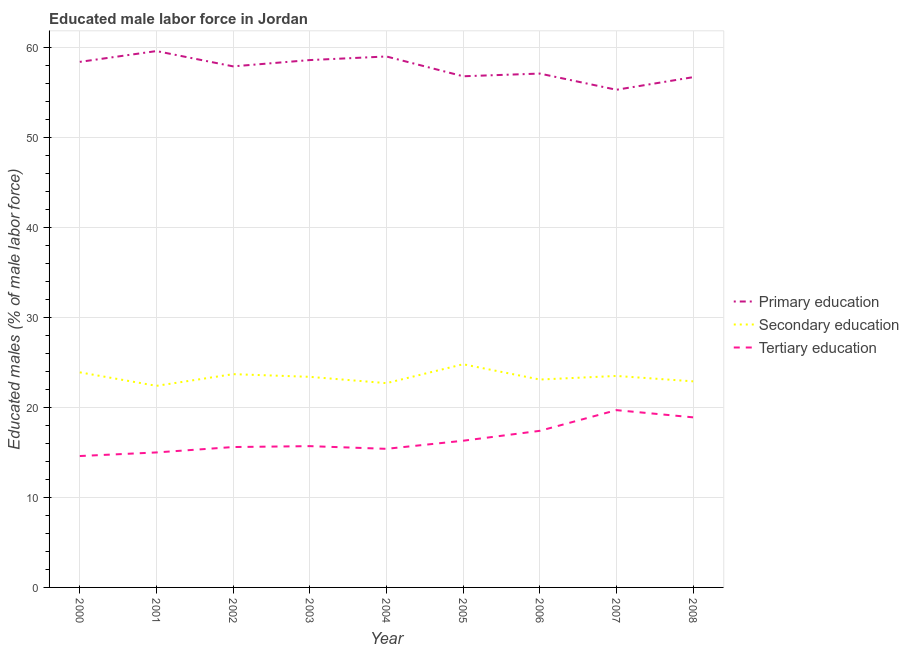What is the percentage of male labor force who received primary education in 2008?
Your answer should be very brief. 56.7. Across all years, what is the maximum percentage of male labor force who received secondary education?
Ensure brevity in your answer.  24.8. Across all years, what is the minimum percentage of male labor force who received secondary education?
Provide a succinct answer. 22.4. In which year was the percentage of male labor force who received primary education maximum?
Give a very brief answer. 2001. In which year was the percentage of male labor force who received secondary education minimum?
Your answer should be compact. 2001. What is the total percentage of male labor force who received tertiary education in the graph?
Provide a short and direct response. 148.6. What is the difference between the percentage of male labor force who received secondary education in 2000 and that in 2005?
Provide a succinct answer. -0.9. What is the difference between the percentage of male labor force who received tertiary education in 2007 and the percentage of male labor force who received primary education in 2003?
Make the answer very short. -38.9. What is the average percentage of male labor force who received tertiary education per year?
Your answer should be compact. 16.51. In the year 2005, what is the difference between the percentage of male labor force who received tertiary education and percentage of male labor force who received primary education?
Offer a terse response. -40.5. In how many years, is the percentage of male labor force who received secondary education greater than 56 %?
Your response must be concise. 0. What is the ratio of the percentage of male labor force who received secondary education in 2001 to that in 2008?
Keep it short and to the point. 0.98. Is the percentage of male labor force who received secondary education in 2000 less than that in 2001?
Give a very brief answer. No. What is the difference between the highest and the second highest percentage of male labor force who received primary education?
Ensure brevity in your answer.  0.6. What is the difference between the highest and the lowest percentage of male labor force who received secondary education?
Your answer should be very brief. 2.4. Does the percentage of male labor force who received primary education monotonically increase over the years?
Provide a succinct answer. No. Is the percentage of male labor force who received primary education strictly greater than the percentage of male labor force who received secondary education over the years?
Provide a succinct answer. Yes. Is the percentage of male labor force who received primary education strictly less than the percentage of male labor force who received secondary education over the years?
Your answer should be very brief. No. How many lines are there?
Provide a succinct answer. 3. How many years are there in the graph?
Your answer should be compact. 9. What is the difference between two consecutive major ticks on the Y-axis?
Your answer should be compact. 10. Does the graph contain any zero values?
Your answer should be very brief. No. Where does the legend appear in the graph?
Your response must be concise. Center right. How are the legend labels stacked?
Keep it short and to the point. Vertical. What is the title of the graph?
Offer a terse response. Educated male labor force in Jordan. Does "Social Protection" appear as one of the legend labels in the graph?
Offer a terse response. No. What is the label or title of the X-axis?
Give a very brief answer. Year. What is the label or title of the Y-axis?
Make the answer very short. Educated males (% of male labor force). What is the Educated males (% of male labor force) of Primary education in 2000?
Provide a short and direct response. 58.4. What is the Educated males (% of male labor force) in Secondary education in 2000?
Your answer should be very brief. 23.9. What is the Educated males (% of male labor force) of Tertiary education in 2000?
Your answer should be very brief. 14.6. What is the Educated males (% of male labor force) of Primary education in 2001?
Keep it short and to the point. 59.6. What is the Educated males (% of male labor force) of Secondary education in 2001?
Offer a very short reply. 22.4. What is the Educated males (% of male labor force) in Primary education in 2002?
Provide a short and direct response. 57.9. What is the Educated males (% of male labor force) of Secondary education in 2002?
Your response must be concise. 23.7. What is the Educated males (% of male labor force) of Tertiary education in 2002?
Offer a very short reply. 15.6. What is the Educated males (% of male labor force) of Primary education in 2003?
Your answer should be very brief. 58.6. What is the Educated males (% of male labor force) of Secondary education in 2003?
Make the answer very short. 23.4. What is the Educated males (% of male labor force) of Tertiary education in 2003?
Offer a very short reply. 15.7. What is the Educated males (% of male labor force) in Secondary education in 2004?
Keep it short and to the point. 22.7. What is the Educated males (% of male labor force) in Tertiary education in 2004?
Your answer should be compact. 15.4. What is the Educated males (% of male labor force) in Primary education in 2005?
Your answer should be very brief. 56.8. What is the Educated males (% of male labor force) in Secondary education in 2005?
Your answer should be compact. 24.8. What is the Educated males (% of male labor force) of Tertiary education in 2005?
Give a very brief answer. 16.3. What is the Educated males (% of male labor force) in Primary education in 2006?
Offer a very short reply. 57.1. What is the Educated males (% of male labor force) of Secondary education in 2006?
Provide a short and direct response. 23.1. What is the Educated males (% of male labor force) in Tertiary education in 2006?
Your answer should be very brief. 17.4. What is the Educated males (% of male labor force) in Primary education in 2007?
Give a very brief answer. 55.3. What is the Educated males (% of male labor force) in Secondary education in 2007?
Offer a very short reply. 23.5. What is the Educated males (% of male labor force) in Tertiary education in 2007?
Your answer should be very brief. 19.7. What is the Educated males (% of male labor force) in Primary education in 2008?
Your response must be concise. 56.7. What is the Educated males (% of male labor force) of Secondary education in 2008?
Your response must be concise. 22.9. What is the Educated males (% of male labor force) in Tertiary education in 2008?
Your response must be concise. 18.9. Across all years, what is the maximum Educated males (% of male labor force) of Primary education?
Provide a short and direct response. 59.6. Across all years, what is the maximum Educated males (% of male labor force) of Secondary education?
Ensure brevity in your answer.  24.8. Across all years, what is the maximum Educated males (% of male labor force) of Tertiary education?
Ensure brevity in your answer.  19.7. Across all years, what is the minimum Educated males (% of male labor force) of Primary education?
Give a very brief answer. 55.3. Across all years, what is the minimum Educated males (% of male labor force) of Secondary education?
Your response must be concise. 22.4. Across all years, what is the minimum Educated males (% of male labor force) of Tertiary education?
Keep it short and to the point. 14.6. What is the total Educated males (% of male labor force) in Primary education in the graph?
Offer a terse response. 519.4. What is the total Educated males (% of male labor force) of Secondary education in the graph?
Offer a terse response. 210.4. What is the total Educated males (% of male labor force) in Tertiary education in the graph?
Your response must be concise. 148.6. What is the difference between the Educated males (% of male labor force) of Primary education in 2000 and that in 2001?
Offer a terse response. -1.2. What is the difference between the Educated males (% of male labor force) in Tertiary education in 2000 and that in 2001?
Provide a short and direct response. -0.4. What is the difference between the Educated males (% of male labor force) in Primary education in 2000 and that in 2002?
Your answer should be compact. 0.5. What is the difference between the Educated males (% of male labor force) of Secondary education in 2000 and that in 2002?
Keep it short and to the point. 0.2. What is the difference between the Educated males (% of male labor force) of Secondary education in 2000 and that in 2003?
Offer a terse response. 0.5. What is the difference between the Educated males (% of male labor force) of Secondary education in 2000 and that in 2004?
Ensure brevity in your answer.  1.2. What is the difference between the Educated males (% of male labor force) of Tertiary education in 2000 and that in 2004?
Offer a terse response. -0.8. What is the difference between the Educated males (% of male labor force) in Primary education in 2000 and that in 2005?
Make the answer very short. 1.6. What is the difference between the Educated males (% of male labor force) in Secondary education in 2000 and that in 2005?
Your response must be concise. -0.9. What is the difference between the Educated males (% of male labor force) of Tertiary education in 2000 and that in 2005?
Keep it short and to the point. -1.7. What is the difference between the Educated males (% of male labor force) of Primary education in 2000 and that in 2006?
Offer a terse response. 1.3. What is the difference between the Educated males (% of male labor force) in Secondary education in 2000 and that in 2006?
Your answer should be compact. 0.8. What is the difference between the Educated males (% of male labor force) in Secondary education in 2000 and that in 2007?
Offer a terse response. 0.4. What is the difference between the Educated males (% of male labor force) of Secondary education in 2000 and that in 2008?
Make the answer very short. 1. What is the difference between the Educated males (% of male labor force) in Tertiary education in 2000 and that in 2008?
Your answer should be very brief. -4.3. What is the difference between the Educated males (% of male labor force) in Secondary education in 2001 and that in 2002?
Your response must be concise. -1.3. What is the difference between the Educated males (% of male labor force) of Tertiary education in 2001 and that in 2002?
Your answer should be compact. -0.6. What is the difference between the Educated males (% of male labor force) in Primary education in 2001 and that in 2003?
Give a very brief answer. 1. What is the difference between the Educated males (% of male labor force) in Tertiary education in 2001 and that in 2003?
Offer a terse response. -0.7. What is the difference between the Educated males (% of male labor force) in Secondary education in 2001 and that in 2004?
Offer a terse response. -0.3. What is the difference between the Educated males (% of male labor force) of Primary education in 2001 and that in 2005?
Ensure brevity in your answer.  2.8. What is the difference between the Educated males (% of male labor force) of Primary education in 2001 and that in 2006?
Give a very brief answer. 2.5. What is the difference between the Educated males (% of male labor force) of Tertiary education in 2001 and that in 2006?
Your response must be concise. -2.4. What is the difference between the Educated males (% of male labor force) in Primary education in 2001 and that in 2007?
Keep it short and to the point. 4.3. What is the difference between the Educated males (% of male labor force) in Primary education in 2001 and that in 2008?
Keep it short and to the point. 2.9. What is the difference between the Educated males (% of male labor force) of Secondary education in 2001 and that in 2008?
Your answer should be compact. -0.5. What is the difference between the Educated males (% of male labor force) of Tertiary education in 2001 and that in 2008?
Give a very brief answer. -3.9. What is the difference between the Educated males (% of male labor force) of Secondary education in 2002 and that in 2004?
Your answer should be very brief. 1. What is the difference between the Educated males (% of male labor force) in Primary education in 2002 and that in 2005?
Ensure brevity in your answer.  1.1. What is the difference between the Educated males (% of male labor force) in Tertiary education in 2002 and that in 2005?
Give a very brief answer. -0.7. What is the difference between the Educated males (% of male labor force) of Primary education in 2002 and that in 2007?
Provide a succinct answer. 2.6. What is the difference between the Educated males (% of male labor force) in Tertiary education in 2002 and that in 2007?
Ensure brevity in your answer.  -4.1. What is the difference between the Educated males (% of male labor force) of Primary education in 2002 and that in 2008?
Offer a very short reply. 1.2. What is the difference between the Educated males (% of male labor force) of Tertiary education in 2002 and that in 2008?
Give a very brief answer. -3.3. What is the difference between the Educated males (% of male labor force) in Primary education in 2003 and that in 2004?
Ensure brevity in your answer.  -0.4. What is the difference between the Educated males (% of male labor force) of Primary education in 2003 and that in 2006?
Provide a short and direct response. 1.5. What is the difference between the Educated males (% of male labor force) in Secondary education in 2003 and that in 2006?
Offer a very short reply. 0.3. What is the difference between the Educated males (% of male labor force) in Primary education in 2003 and that in 2007?
Your answer should be very brief. 3.3. What is the difference between the Educated males (% of male labor force) in Secondary education in 2003 and that in 2007?
Give a very brief answer. -0.1. What is the difference between the Educated males (% of male labor force) in Primary education in 2003 and that in 2008?
Make the answer very short. 1.9. What is the difference between the Educated males (% of male labor force) in Secondary education in 2003 and that in 2008?
Your response must be concise. 0.5. What is the difference between the Educated males (% of male labor force) in Tertiary education in 2003 and that in 2008?
Provide a succinct answer. -3.2. What is the difference between the Educated males (% of male labor force) of Secondary education in 2004 and that in 2005?
Provide a succinct answer. -2.1. What is the difference between the Educated males (% of male labor force) in Primary education in 2004 and that in 2006?
Give a very brief answer. 1.9. What is the difference between the Educated males (% of male labor force) of Tertiary education in 2004 and that in 2006?
Make the answer very short. -2. What is the difference between the Educated males (% of male labor force) in Primary education in 2004 and that in 2007?
Provide a succinct answer. 3.7. What is the difference between the Educated males (% of male labor force) of Tertiary education in 2004 and that in 2007?
Offer a terse response. -4.3. What is the difference between the Educated males (% of male labor force) of Secondary education in 2005 and that in 2006?
Offer a very short reply. 1.7. What is the difference between the Educated males (% of male labor force) of Primary education in 2005 and that in 2007?
Give a very brief answer. 1.5. What is the difference between the Educated males (% of male labor force) in Secondary education in 2005 and that in 2007?
Your answer should be compact. 1.3. What is the difference between the Educated males (% of male labor force) of Tertiary education in 2005 and that in 2007?
Ensure brevity in your answer.  -3.4. What is the difference between the Educated males (% of male labor force) of Secondary education in 2005 and that in 2008?
Your answer should be compact. 1.9. What is the difference between the Educated males (% of male labor force) in Tertiary education in 2005 and that in 2008?
Your response must be concise. -2.6. What is the difference between the Educated males (% of male labor force) of Primary education in 2006 and that in 2007?
Provide a succinct answer. 1.8. What is the difference between the Educated males (% of male labor force) in Secondary education in 2006 and that in 2007?
Your answer should be very brief. -0.4. What is the difference between the Educated males (% of male labor force) in Secondary education in 2006 and that in 2008?
Provide a succinct answer. 0.2. What is the difference between the Educated males (% of male labor force) in Secondary education in 2007 and that in 2008?
Provide a short and direct response. 0.6. What is the difference between the Educated males (% of male labor force) of Primary education in 2000 and the Educated males (% of male labor force) of Tertiary education in 2001?
Your answer should be compact. 43.4. What is the difference between the Educated males (% of male labor force) of Secondary education in 2000 and the Educated males (% of male labor force) of Tertiary education in 2001?
Keep it short and to the point. 8.9. What is the difference between the Educated males (% of male labor force) of Primary education in 2000 and the Educated males (% of male labor force) of Secondary education in 2002?
Provide a short and direct response. 34.7. What is the difference between the Educated males (% of male labor force) in Primary education in 2000 and the Educated males (% of male labor force) in Tertiary education in 2002?
Your answer should be compact. 42.8. What is the difference between the Educated males (% of male labor force) in Primary education in 2000 and the Educated males (% of male labor force) in Tertiary education in 2003?
Provide a succinct answer. 42.7. What is the difference between the Educated males (% of male labor force) of Primary education in 2000 and the Educated males (% of male labor force) of Secondary education in 2004?
Ensure brevity in your answer.  35.7. What is the difference between the Educated males (% of male labor force) in Primary education in 2000 and the Educated males (% of male labor force) in Tertiary education in 2004?
Keep it short and to the point. 43. What is the difference between the Educated males (% of male labor force) of Primary education in 2000 and the Educated males (% of male labor force) of Secondary education in 2005?
Keep it short and to the point. 33.6. What is the difference between the Educated males (% of male labor force) of Primary education in 2000 and the Educated males (% of male labor force) of Tertiary education in 2005?
Your answer should be compact. 42.1. What is the difference between the Educated males (% of male labor force) of Secondary education in 2000 and the Educated males (% of male labor force) of Tertiary education in 2005?
Provide a short and direct response. 7.6. What is the difference between the Educated males (% of male labor force) of Primary education in 2000 and the Educated males (% of male labor force) of Secondary education in 2006?
Make the answer very short. 35.3. What is the difference between the Educated males (% of male labor force) of Primary education in 2000 and the Educated males (% of male labor force) of Tertiary education in 2006?
Your response must be concise. 41. What is the difference between the Educated males (% of male labor force) of Secondary education in 2000 and the Educated males (% of male labor force) of Tertiary education in 2006?
Your answer should be very brief. 6.5. What is the difference between the Educated males (% of male labor force) of Primary education in 2000 and the Educated males (% of male labor force) of Secondary education in 2007?
Provide a succinct answer. 34.9. What is the difference between the Educated males (% of male labor force) of Primary education in 2000 and the Educated males (% of male labor force) of Tertiary education in 2007?
Provide a short and direct response. 38.7. What is the difference between the Educated males (% of male labor force) of Secondary education in 2000 and the Educated males (% of male labor force) of Tertiary education in 2007?
Give a very brief answer. 4.2. What is the difference between the Educated males (% of male labor force) of Primary education in 2000 and the Educated males (% of male labor force) of Secondary education in 2008?
Your response must be concise. 35.5. What is the difference between the Educated males (% of male labor force) of Primary education in 2000 and the Educated males (% of male labor force) of Tertiary education in 2008?
Give a very brief answer. 39.5. What is the difference between the Educated males (% of male labor force) in Primary education in 2001 and the Educated males (% of male labor force) in Secondary education in 2002?
Give a very brief answer. 35.9. What is the difference between the Educated males (% of male labor force) in Primary education in 2001 and the Educated males (% of male labor force) in Tertiary education in 2002?
Provide a short and direct response. 44. What is the difference between the Educated males (% of male labor force) in Primary education in 2001 and the Educated males (% of male labor force) in Secondary education in 2003?
Offer a very short reply. 36.2. What is the difference between the Educated males (% of male labor force) in Primary education in 2001 and the Educated males (% of male labor force) in Tertiary education in 2003?
Give a very brief answer. 43.9. What is the difference between the Educated males (% of male labor force) of Secondary education in 2001 and the Educated males (% of male labor force) of Tertiary education in 2003?
Keep it short and to the point. 6.7. What is the difference between the Educated males (% of male labor force) of Primary education in 2001 and the Educated males (% of male labor force) of Secondary education in 2004?
Offer a very short reply. 36.9. What is the difference between the Educated males (% of male labor force) in Primary education in 2001 and the Educated males (% of male labor force) in Tertiary education in 2004?
Provide a succinct answer. 44.2. What is the difference between the Educated males (% of male labor force) of Primary education in 2001 and the Educated males (% of male labor force) of Secondary education in 2005?
Your answer should be compact. 34.8. What is the difference between the Educated males (% of male labor force) in Primary education in 2001 and the Educated males (% of male labor force) in Tertiary education in 2005?
Ensure brevity in your answer.  43.3. What is the difference between the Educated males (% of male labor force) of Secondary education in 2001 and the Educated males (% of male labor force) of Tertiary education in 2005?
Keep it short and to the point. 6.1. What is the difference between the Educated males (% of male labor force) in Primary education in 2001 and the Educated males (% of male labor force) in Secondary education in 2006?
Provide a short and direct response. 36.5. What is the difference between the Educated males (% of male labor force) of Primary education in 2001 and the Educated males (% of male labor force) of Tertiary education in 2006?
Provide a succinct answer. 42.2. What is the difference between the Educated males (% of male labor force) of Secondary education in 2001 and the Educated males (% of male labor force) of Tertiary education in 2006?
Your response must be concise. 5. What is the difference between the Educated males (% of male labor force) in Primary education in 2001 and the Educated males (% of male labor force) in Secondary education in 2007?
Offer a very short reply. 36.1. What is the difference between the Educated males (% of male labor force) in Primary education in 2001 and the Educated males (% of male labor force) in Tertiary education in 2007?
Give a very brief answer. 39.9. What is the difference between the Educated males (% of male labor force) of Primary education in 2001 and the Educated males (% of male labor force) of Secondary education in 2008?
Offer a very short reply. 36.7. What is the difference between the Educated males (% of male labor force) in Primary education in 2001 and the Educated males (% of male labor force) in Tertiary education in 2008?
Keep it short and to the point. 40.7. What is the difference between the Educated males (% of male labor force) of Primary education in 2002 and the Educated males (% of male labor force) of Secondary education in 2003?
Provide a short and direct response. 34.5. What is the difference between the Educated males (% of male labor force) of Primary education in 2002 and the Educated males (% of male labor force) of Tertiary education in 2003?
Give a very brief answer. 42.2. What is the difference between the Educated males (% of male labor force) of Primary education in 2002 and the Educated males (% of male labor force) of Secondary education in 2004?
Your answer should be very brief. 35.2. What is the difference between the Educated males (% of male labor force) in Primary education in 2002 and the Educated males (% of male labor force) in Tertiary education in 2004?
Provide a succinct answer. 42.5. What is the difference between the Educated males (% of male labor force) of Primary education in 2002 and the Educated males (% of male labor force) of Secondary education in 2005?
Your answer should be very brief. 33.1. What is the difference between the Educated males (% of male labor force) of Primary education in 2002 and the Educated males (% of male labor force) of Tertiary education in 2005?
Your answer should be compact. 41.6. What is the difference between the Educated males (% of male labor force) of Secondary education in 2002 and the Educated males (% of male labor force) of Tertiary education in 2005?
Provide a short and direct response. 7.4. What is the difference between the Educated males (% of male labor force) of Primary education in 2002 and the Educated males (% of male labor force) of Secondary education in 2006?
Provide a succinct answer. 34.8. What is the difference between the Educated males (% of male labor force) in Primary education in 2002 and the Educated males (% of male labor force) in Tertiary education in 2006?
Ensure brevity in your answer.  40.5. What is the difference between the Educated males (% of male labor force) in Secondary education in 2002 and the Educated males (% of male labor force) in Tertiary education in 2006?
Provide a short and direct response. 6.3. What is the difference between the Educated males (% of male labor force) of Primary education in 2002 and the Educated males (% of male labor force) of Secondary education in 2007?
Offer a terse response. 34.4. What is the difference between the Educated males (% of male labor force) of Primary education in 2002 and the Educated males (% of male labor force) of Tertiary education in 2007?
Your answer should be very brief. 38.2. What is the difference between the Educated males (% of male labor force) of Secondary education in 2002 and the Educated males (% of male labor force) of Tertiary education in 2007?
Provide a short and direct response. 4. What is the difference between the Educated males (% of male labor force) in Primary education in 2002 and the Educated males (% of male labor force) in Secondary education in 2008?
Offer a terse response. 35. What is the difference between the Educated males (% of male labor force) of Primary education in 2003 and the Educated males (% of male labor force) of Secondary education in 2004?
Offer a very short reply. 35.9. What is the difference between the Educated males (% of male labor force) of Primary education in 2003 and the Educated males (% of male labor force) of Tertiary education in 2004?
Offer a terse response. 43.2. What is the difference between the Educated males (% of male labor force) in Primary education in 2003 and the Educated males (% of male labor force) in Secondary education in 2005?
Offer a terse response. 33.8. What is the difference between the Educated males (% of male labor force) in Primary education in 2003 and the Educated males (% of male labor force) in Tertiary education in 2005?
Your answer should be very brief. 42.3. What is the difference between the Educated males (% of male labor force) in Primary education in 2003 and the Educated males (% of male labor force) in Secondary education in 2006?
Make the answer very short. 35.5. What is the difference between the Educated males (% of male labor force) in Primary education in 2003 and the Educated males (% of male labor force) in Tertiary education in 2006?
Make the answer very short. 41.2. What is the difference between the Educated males (% of male labor force) of Primary education in 2003 and the Educated males (% of male labor force) of Secondary education in 2007?
Keep it short and to the point. 35.1. What is the difference between the Educated males (% of male labor force) in Primary education in 2003 and the Educated males (% of male labor force) in Tertiary education in 2007?
Give a very brief answer. 38.9. What is the difference between the Educated males (% of male labor force) of Secondary education in 2003 and the Educated males (% of male labor force) of Tertiary education in 2007?
Keep it short and to the point. 3.7. What is the difference between the Educated males (% of male labor force) in Primary education in 2003 and the Educated males (% of male labor force) in Secondary education in 2008?
Keep it short and to the point. 35.7. What is the difference between the Educated males (% of male labor force) in Primary education in 2003 and the Educated males (% of male labor force) in Tertiary education in 2008?
Ensure brevity in your answer.  39.7. What is the difference between the Educated males (% of male labor force) in Secondary education in 2003 and the Educated males (% of male labor force) in Tertiary education in 2008?
Keep it short and to the point. 4.5. What is the difference between the Educated males (% of male labor force) of Primary education in 2004 and the Educated males (% of male labor force) of Secondary education in 2005?
Provide a short and direct response. 34.2. What is the difference between the Educated males (% of male labor force) in Primary education in 2004 and the Educated males (% of male labor force) in Tertiary education in 2005?
Make the answer very short. 42.7. What is the difference between the Educated males (% of male labor force) of Primary education in 2004 and the Educated males (% of male labor force) of Secondary education in 2006?
Provide a short and direct response. 35.9. What is the difference between the Educated males (% of male labor force) of Primary education in 2004 and the Educated males (% of male labor force) of Tertiary education in 2006?
Provide a succinct answer. 41.6. What is the difference between the Educated males (% of male labor force) of Primary education in 2004 and the Educated males (% of male labor force) of Secondary education in 2007?
Provide a short and direct response. 35.5. What is the difference between the Educated males (% of male labor force) in Primary education in 2004 and the Educated males (% of male labor force) in Tertiary education in 2007?
Make the answer very short. 39.3. What is the difference between the Educated males (% of male labor force) of Secondary education in 2004 and the Educated males (% of male labor force) of Tertiary education in 2007?
Offer a terse response. 3. What is the difference between the Educated males (% of male labor force) of Primary education in 2004 and the Educated males (% of male labor force) of Secondary education in 2008?
Your answer should be compact. 36.1. What is the difference between the Educated males (% of male labor force) of Primary education in 2004 and the Educated males (% of male labor force) of Tertiary education in 2008?
Your answer should be very brief. 40.1. What is the difference between the Educated males (% of male labor force) of Primary education in 2005 and the Educated males (% of male labor force) of Secondary education in 2006?
Make the answer very short. 33.7. What is the difference between the Educated males (% of male labor force) of Primary education in 2005 and the Educated males (% of male labor force) of Tertiary education in 2006?
Your answer should be very brief. 39.4. What is the difference between the Educated males (% of male labor force) of Primary education in 2005 and the Educated males (% of male labor force) of Secondary education in 2007?
Provide a short and direct response. 33.3. What is the difference between the Educated males (% of male labor force) of Primary education in 2005 and the Educated males (% of male labor force) of Tertiary education in 2007?
Give a very brief answer. 37.1. What is the difference between the Educated males (% of male labor force) of Primary education in 2005 and the Educated males (% of male labor force) of Secondary education in 2008?
Provide a short and direct response. 33.9. What is the difference between the Educated males (% of male labor force) in Primary education in 2005 and the Educated males (% of male labor force) in Tertiary education in 2008?
Offer a terse response. 37.9. What is the difference between the Educated males (% of male labor force) in Secondary education in 2005 and the Educated males (% of male labor force) in Tertiary education in 2008?
Your answer should be very brief. 5.9. What is the difference between the Educated males (% of male labor force) of Primary education in 2006 and the Educated males (% of male labor force) of Secondary education in 2007?
Ensure brevity in your answer.  33.6. What is the difference between the Educated males (% of male labor force) in Primary education in 2006 and the Educated males (% of male labor force) in Tertiary education in 2007?
Give a very brief answer. 37.4. What is the difference between the Educated males (% of male labor force) in Secondary education in 2006 and the Educated males (% of male labor force) in Tertiary education in 2007?
Make the answer very short. 3.4. What is the difference between the Educated males (% of male labor force) in Primary education in 2006 and the Educated males (% of male labor force) in Secondary education in 2008?
Provide a short and direct response. 34.2. What is the difference between the Educated males (% of male labor force) in Primary education in 2006 and the Educated males (% of male labor force) in Tertiary education in 2008?
Your answer should be very brief. 38.2. What is the difference between the Educated males (% of male labor force) in Primary education in 2007 and the Educated males (% of male labor force) in Secondary education in 2008?
Provide a short and direct response. 32.4. What is the difference between the Educated males (% of male labor force) in Primary education in 2007 and the Educated males (% of male labor force) in Tertiary education in 2008?
Make the answer very short. 36.4. What is the average Educated males (% of male labor force) of Primary education per year?
Offer a terse response. 57.71. What is the average Educated males (% of male labor force) in Secondary education per year?
Ensure brevity in your answer.  23.38. What is the average Educated males (% of male labor force) of Tertiary education per year?
Offer a terse response. 16.51. In the year 2000, what is the difference between the Educated males (% of male labor force) of Primary education and Educated males (% of male labor force) of Secondary education?
Make the answer very short. 34.5. In the year 2000, what is the difference between the Educated males (% of male labor force) in Primary education and Educated males (% of male labor force) in Tertiary education?
Give a very brief answer. 43.8. In the year 2000, what is the difference between the Educated males (% of male labor force) of Secondary education and Educated males (% of male labor force) of Tertiary education?
Provide a short and direct response. 9.3. In the year 2001, what is the difference between the Educated males (% of male labor force) in Primary education and Educated males (% of male labor force) in Secondary education?
Your answer should be very brief. 37.2. In the year 2001, what is the difference between the Educated males (% of male labor force) in Primary education and Educated males (% of male labor force) in Tertiary education?
Offer a very short reply. 44.6. In the year 2001, what is the difference between the Educated males (% of male labor force) in Secondary education and Educated males (% of male labor force) in Tertiary education?
Provide a succinct answer. 7.4. In the year 2002, what is the difference between the Educated males (% of male labor force) in Primary education and Educated males (% of male labor force) in Secondary education?
Give a very brief answer. 34.2. In the year 2002, what is the difference between the Educated males (% of male labor force) of Primary education and Educated males (% of male labor force) of Tertiary education?
Offer a very short reply. 42.3. In the year 2002, what is the difference between the Educated males (% of male labor force) in Secondary education and Educated males (% of male labor force) in Tertiary education?
Ensure brevity in your answer.  8.1. In the year 2003, what is the difference between the Educated males (% of male labor force) of Primary education and Educated males (% of male labor force) of Secondary education?
Provide a short and direct response. 35.2. In the year 2003, what is the difference between the Educated males (% of male labor force) of Primary education and Educated males (% of male labor force) of Tertiary education?
Your response must be concise. 42.9. In the year 2003, what is the difference between the Educated males (% of male labor force) of Secondary education and Educated males (% of male labor force) of Tertiary education?
Your answer should be very brief. 7.7. In the year 2004, what is the difference between the Educated males (% of male labor force) in Primary education and Educated males (% of male labor force) in Secondary education?
Provide a succinct answer. 36.3. In the year 2004, what is the difference between the Educated males (% of male labor force) in Primary education and Educated males (% of male labor force) in Tertiary education?
Make the answer very short. 43.6. In the year 2005, what is the difference between the Educated males (% of male labor force) in Primary education and Educated males (% of male labor force) in Tertiary education?
Provide a short and direct response. 40.5. In the year 2005, what is the difference between the Educated males (% of male labor force) of Secondary education and Educated males (% of male labor force) of Tertiary education?
Provide a succinct answer. 8.5. In the year 2006, what is the difference between the Educated males (% of male labor force) of Primary education and Educated males (% of male labor force) of Tertiary education?
Your answer should be compact. 39.7. In the year 2007, what is the difference between the Educated males (% of male labor force) in Primary education and Educated males (% of male labor force) in Secondary education?
Provide a short and direct response. 31.8. In the year 2007, what is the difference between the Educated males (% of male labor force) of Primary education and Educated males (% of male labor force) of Tertiary education?
Your response must be concise. 35.6. In the year 2008, what is the difference between the Educated males (% of male labor force) of Primary education and Educated males (% of male labor force) of Secondary education?
Provide a succinct answer. 33.8. In the year 2008, what is the difference between the Educated males (% of male labor force) in Primary education and Educated males (% of male labor force) in Tertiary education?
Offer a very short reply. 37.8. In the year 2008, what is the difference between the Educated males (% of male labor force) in Secondary education and Educated males (% of male labor force) in Tertiary education?
Keep it short and to the point. 4. What is the ratio of the Educated males (% of male labor force) of Primary education in 2000 to that in 2001?
Your answer should be very brief. 0.98. What is the ratio of the Educated males (% of male labor force) in Secondary education in 2000 to that in 2001?
Provide a short and direct response. 1.07. What is the ratio of the Educated males (% of male labor force) in Tertiary education in 2000 to that in 2001?
Provide a succinct answer. 0.97. What is the ratio of the Educated males (% of male labor force) in Primary education in 2000 to that in 2002?
Your answer should be very brief. 1.01. What is the ratio of the Educated males (% of male labor force) of Secondary education in 2000 to that in 2002?
Keep it short and to the point. 1.01. What is the ratio of the Educated males (% of male labor force) in Tertiary education in 2000 to that in 2002?
Keep it short and to the point. 0.94. What is the ratio of the Educated males (% of male labor force) of Primary education in 2000 to that in 2003?
Your response must be concise. 1. What is the ratio of the Educated males (% of male labor force) of Secondary education in 2000 to that in 2003?
Your answer should be very brief. 1.02. What is the ratio of the Educated males (% of male labor force) in Tertiary education in 2000 to that in 2003?
Offer a terse response. 0.93. What is the ratio of the Educated males (% of male labor force) of Primary education in 2000 to that in 2004?
Your response must be concise. 0.99. What is the ratio of the Educated males (% of male labor force) in Secondary education in 2000 to that in 2004?
Provide a short and direct response. 1.05. What is the ratio of the Educated males (% of male labor force) of Tertiary education in 2000 to that in 2004?
Your response must be concise. 0.95. What is the ratio of the Educated males (% of male labor force) in Primary education in 2000 to that in 2005?
Give a very brief answer. 1.03. What is the ratio of the Educated males (% of male labor force) of Secondary education in 2000 to that in 2005?
Make the answer very short. 0.96. What is the ratio of the Educated males (% of male labor force) in Tertiary education in 2000 to that in 2005?
Provide a succinct answer. 0.9. What is the ratio of the Educated males (% of male labor force) of Primary education in 2000 to that in 2006?
Provide a short and direct response. 1.02. What is the ratio of the Educated males (% of male labor force) of Secondary education in 2000 to that in 2006?
Keep it short and to the point. 1.03. What is the ratio of the Educated males (% of male labor force) in Tertiary education in 2000 to that in 2006?
Keep it short and to the point. 0.84. What is the ratio of the Educated males (% of male labor force) in Primary education in 2000 to that in 2007?
Ensure brevity in your answer.  1.06. What is the ratio of the Educated males (% of male labor force) in Tertiary education in 2000 to that in 2007?
Make the answer very short. 0.74. What is the ratio of the Educated males (% of male labor force) of Secondary education in 2000 to that in 2008?
Your answer should be very brief. 1.04. What is the ratio of the Educated males (% of male labor force) of Tertiary education in 2000 to that in 2008?
Give a very brief answer. 0.77. What is the ratio of the Educated males (% of male labor force) in Primary education in 2001 to that in 2002?
Ensure brevity in your answer.  1.03. What is the ratio of the Educated males (% of male labor force) in Secondary education in 2001 to that in 2002?
Provide a short and direct response. 0.95. What is the ratio of the Educated males (% of male labor force) of Tertiary education in 2001 to that in 2002?
Your answer should be compact. 0.96. What is the ratio of the Educated males (% of male labor force) of Primary education in 2001 to that in 2003?
Ensure brevity in your answer.  1.02. What is the ratio of the Educated males (% of male labor force) in Secondary education in 2001 to that in 2003?
Your answer should be compact. 0.96. What is the ratio of the Educated males (% of male labor force) of Tertiary education in 2001 to that in 2003?
Your answer should be very brief. 0.96. What is the ratio of the Educated males (% of male labor force) in Primary education in 2001 to that in 2004?
Offer a very short reply. 1.01. What is the ratio of the Educated males (% of male labor force) of Tertiary education in 2001 to that in 2004?
Provide a succinct answer. 0.97. What is the ratio of the Educated males (% of male labor force) in Primary education in 2001 to that in 2005?
Offer a terse response. 1.05. What is the ratio of the Educated males (% of male labor force) in Secondary education in 2001 to that in 2005?
Your response must be concise. 0.9. What is the ratio of the Educated males (% of male labor force) in Tertiary education in 2001 to that in 2005?
Give a very brief answer. 0.92. What is the ratio of the Educated males (% of male labor force) in Primary education in 2001 to that in 2006?
Make the answer very short. 1.04. What is the ratio of the Educated males (% of male labor force) in Secondary education in 2001 to that in 2006?
Provide a succinct answer. 0.97. What is the ratio of the Educated males (% of male labor force) in Tertiary education in 2001 to that in 2006?
Your answer should be compact. 0.86. What is the ratio of the Educated males (% of male labor force) of Primary education in 2001 to that in 2007?
Offer a terse response. 1.08. What is the ratio of the Educated males (% of male labor force) in Secondary education in 2001 to that in 2007?
Your answer should be compact. 0.95. What is the ratio of the Educated males (% of male labor force) of Tertiary education in 2001 to that in 2007?
Your answer should be compact. 0.76. What is the ratio of the Educated males (% of male labor force) of Primary education in 2001 to that in 2008?
Give a very brief answer. 1.05. What is the ratio of the Educated males (% of male labor force) in Secondary education in 2001 to that in 2008?
Your answer should be compact. 0.98. What is the ratio of the Educated males (% of male labor force) of Tertiary education in 2001 to that in 2008?
Your answer should be compact. 0.79. What is the ratio of the Educated males (% of male labor force) in Primary education in 2002 to that in 2003?
Offer a very short reply. 0.99. What is the ratio of the Educated males (% of male labor force) in Secondary education in 2002 to that in 2003?
Make the answer very short. 1.01. What is the ratio of the Educated males (% of male labor force) in Tertiary education in 2002 to that in 2003?
Offer a terse response. 0.99. What is the ratio of the Educated males (% of male labor force) in Primary education in 2002 to that in 2004?
Your response must be concise. 0.98. What is the ratio of the Educated males (% of male labor force) of Secondary education in 2002 to that in 2004?
Your answer should be compact. 1.04. What is the ratio of the Educated males (% of male labor force) in Tertiary education in 2002 to that in 2004?
Your response must be concise. 1.01. What is the ratio of the Educated males (% of male labor force) in Primary education in 2002 to that in 2005?
Offer a very short reply. 1.02. What is the ratio of the Educated males (% of male labor force) in Secondary education in 2002 to that in 2005?
Give a very brief answer. 0.96. What is the ratio of the Educated males (% of male labor force) in Tertiary education in 2002 to that in 2005?
Offer a very short reply. 0.96. What is the ratio of the Educated males (% of male labor force) of Secondary education in 2002 to that in 2006?
Provide a succinct answer. 1.03. What is the ratio of the Educated males (% of male labor force) in Tertiary education in 2002 to that in 2006?
Your answer should be compact. 0.9. What is the ratio of the Educated males (% of male labor force) of Primary education in 2002 to that in 2007?
Your answer should be very brief. 1.05. What is the ratio of the Educated males (% of male labor force) of Secondary education in 2002 to that in 2007?
Keep it short and to the point. 1.01. What is the ratio of the Educated males (% of male labor force) of Tertiary education in 2002 to that in 2007?
Provide a succinct answer. 0.79. What is the ratio of the Educated males (% of male labor force) of Primary education in 2002 to that in 2008?
Offer a terse response. 1.02. What is the ratio of the Educated males (% of male labor force) of Secondary education in 2002 to that in 2008?
Offer a terse response. 1.03. What is the ratio of the Educated males (% of male labor force) in Tertiary education in 2002 to that in 2008?
Provide a short and direct response. 0.83. What is the ratio of the Educated males (% of male labor force) in Secondary education in 2003 to that in 2004?
Your answer should be compact. 1.03. What is the ratio of the Educated males (% of male labor force) in Tertiary education in 2003 to that in 2004?
Keep it short and to the point. 1.02. What is the ratio of the Educated males (% of male labor force) in Primary education in 2003 to that in 2005?
Provide a succinct answer. 1.03. What is the ratio of the Educated males (% of male labor force) in Secondary education in 2003 to that in 2005?
Ensure brevity in your answer.  0.94. What is the ratio of the Educated males (% of male labor force) of Tertiary education in 2003 to that in 2005?
Give a very brief answer. 0.96. What is the ratio of the Educated males (% of male labor force) in Primary education in 2003 to that in 2006?
Your answer should be compact. 1.03. What is the ratio of the Educated males (% of male labor force) in Tertiary education in 2003 to that in 2006?
Offer a very short reply. 0.9. What is the ratio of the Educated males (% of male labor force) in Primary education in 2003 to that in 2007?
Your answer should be compact. 1.06. What is the ratio of the Educated males (% of male labor force) in Secondary education in 2003 to that in 2007?
Your answer should be compact. 1. What is the ratio of the Educated males (% of male labor force) in Tertiary education in 2003 to that in 2007?
Give a very brief answer. 0.8. What is the ratio of the Educated males (% of male labor force) in Primary education in 2003 to that in 2008?
Give a very brief answer. 1.03. What is the ratio of the Educated males (% of male labor force) of Secondary education in 2003 to that in 2008?
Provide a short and direct response. 1.02. What is the ratio of the Educated males (% of male labor force) in Tertiary education in 2003 to that in 2008?
Your response must be concise. 0.83. What is the ratio of the Educated males (% of male labor force) of Primary education in 2004 to that in 2005?
Your answer should be compact. 1.04. What is the ratio of the Educated males (% of male labor force) in Secondary education in 2004 to that in 2005?
Your response must be concise. 0.92. What is the ratio of the Educated males (% of male labor force) of Tertiary education in 2004 to that in 2005?
Offer a very short reply. 0.94. What is the ratio of the Educated males (% of male labor force) in Primary education in 2004 to that in 2006?
Give a very brief answer. 1.03. What is the ratio of the Educated males (% of male labor force) in Secondary education in 2004 to that in 2006?
Provide a short and direct response. 0.98. What is the ratio of the Educated males (% of male labor force) of Tertiary education in 2004 to that in 2006?
Your response must be concise. 0.89. What is the ratio of the Educated males (% of male labor force) of Primary education in 2004 to that in 2007?
Give a very brief answer. 1.07. What is the ratio of the Educated males (% of male labor force) in Secondary education in 2004 to that in 2007?
Provide a succinct answer. 0.97. What is the ratio of the Educated males (% of male labor force) of Tertiary education in 2004 to that in 2007?
Offer a terse response. 0.78. What is the ratio of the Educated males (% of male labor force) in Primary education in 2004 to that in 2008?
Make the answer very short. 1.04. What is the ratio of the Educated males (% of male labor force) in Tertiary education in 2004 to that in 2008?
Give a very brief answer. 0.81. What is the ratio of the Educated males (% of male labor force) of Secondary education in 2005 to that in 2006?
Offer a very short reply. 1.07. What is the ratio of the Educated males (% of male labor force) in Tertiary education in 2005 to that in 2006?
Provide a succinct answer. 0.94. What is the ratio of the Educated males (% of male labor force) in Primary education in 2005 to that in 2007?
Offer a terse response. 1.03. What is the ratio of the Educated males (% of male labor force) in Secondary education in 2005 to that in 2007?
Offer a terse response. 1.06. What is the ratio of the Educated males (% of male labor force) in Tertiary education in 2005 to that in 2007?
Your answer should be very brief. 0.83. What is the ratio of the Educated males (% of male labor force) in Secondary education in 2005 to that in 2008?
Provide a succinct answer. 1.08. What is the ratio of the Educated males (% of male labor force) in Tertiary education in 2005 to that in 2008?
Your answer should be very brief. 0.86. What is the ratio of the Educated males (% of male labor force) of Primary education in 2006 to that in 2007?
Offer a very short reply. 1.03. What is the ratio of the Educated males (% of male labor force) of Tertiary education in 2006 to that in 2007?
Provide a succinct answer. 0.88. What is the ratio of the Educated males (% of male labor force) in Primary education in 2006 to that in 2008?
Give a very brief answer. 1.01. What is the ratio of the Educated males (% of male labor force) in Secondary education in 2006 to that in 2008?
Your answer should be very brief. 1.01. What is the ratio of the Educated males (% of male labor force) in Tertiary education in 2006 to that in 2008?
Offer a terse response. 0.92. What is the ratio of the Educated males (% of male labor force) in Primary education in 2007 to that in 2008?
Ensure brevity in your answer.  0.98. What is the ratio of the Educated males (% of male labor force) of Secondary education in 2007 to that in 2008?
Your response must be concise. 1.03. What is the ratio of the Educated males (% of male labor force) in Tertiary education in 2007 to that in 2008?
Provide a succinct answer. 1.04. What is the difference between the highest and the second highest Educated males (% of male labor force) in Primary education?
Provide a succinct answer. 0.6. What is the difference between the highest and the second highest Educated males (% of male labor force) of Tertiary education?
Your answer should be very brief. 0.8. What is the difference between the highest and the lowest Educated males (% of male labor force) of Primary education?
Offer a very short reply. 4.3. 